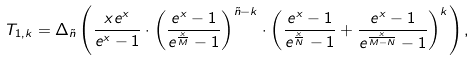<formula> <loc_0><loc_0><loc_500><loc_500>T _ { 1 , k } & = \Delta _ { \tilde { n } } \left ( \frac { x e ^ { x } } { e ^ { x } - 1 } \cdot \left ( \frac { e ^ { x } - 1 } { e ^ { \frac { x } { M } } - 1 } \right ) ^ { \tilde { n } - k } \cdot \left ( \frac { e ^ { x } - 1 } { e ^ { \frac { x } { N } } - 1 } + \frac { e ^ { x } - 1 } { e ^ { \frac { x } { M - N } } - 1 } \right ) ^ { k } \right ) ,</formula> 